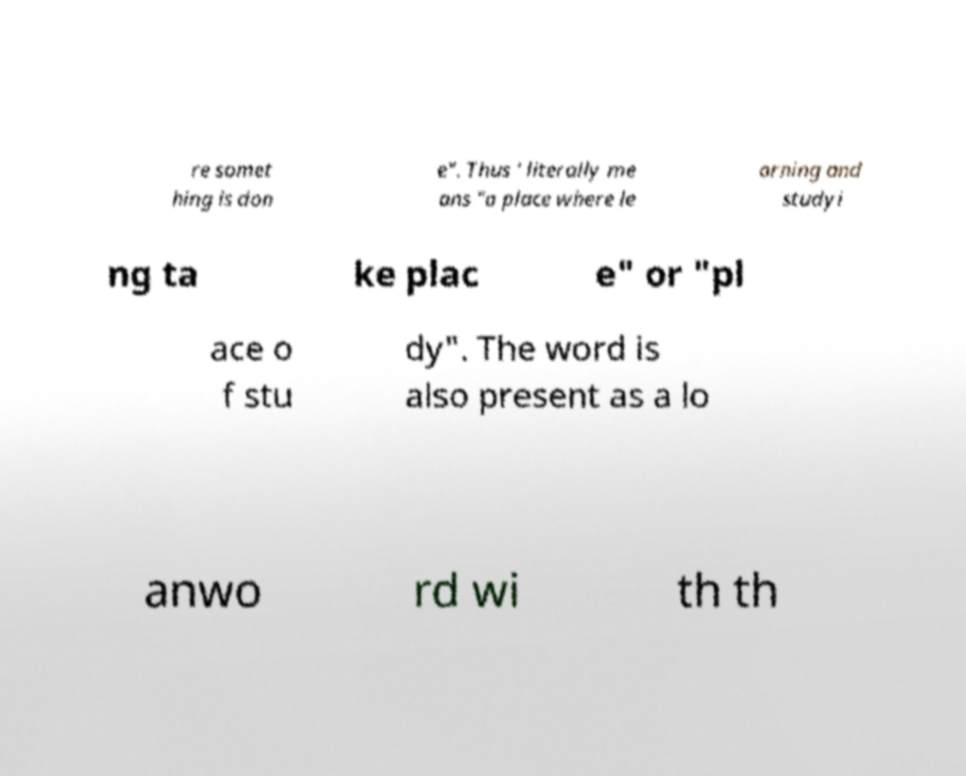Could you extract and type out the text from this image? re somet hing is don e". Thus ' literally me ans "a place where le arning and studyi ng ta ke plac e" or "pl ace o f stu dy". The word is also present as a lo anwo rd wi th th 